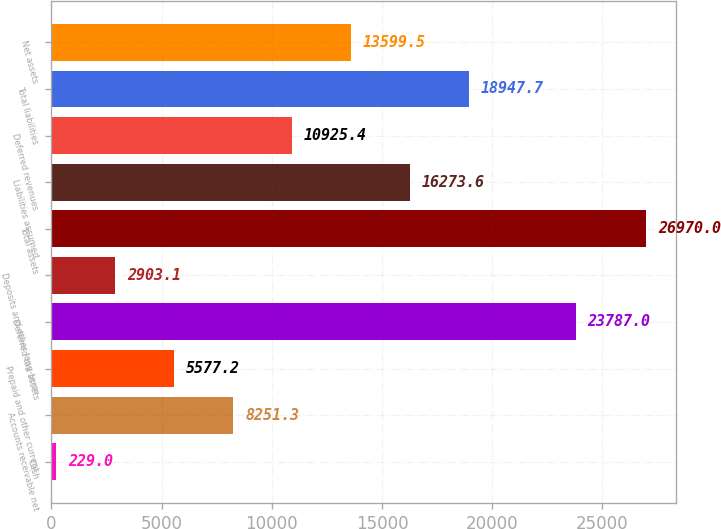Convert chart. <chart><loc_0><loc_0><loc_500><loc_500><bar_chart><fcel>Cash<fcel>Accounts receivable net<fcel>Prepaid and other current<fcel>Deferred tax assets<fcel>Deposits and other long-term<fcel>Total assets<fcel>Liabilities assumed<fcel>Deferred revenues<fcel>Total liabilities<fcel>Net assets<nl><fcel>229<fcel>8251.3<fcel>5577.2<fcel>23787<fcel>2903.1<fcel>26970<fcel>16273.6<fcel>10925.4<fcel>18947.7<fcel>13599.5<nl></chart> 